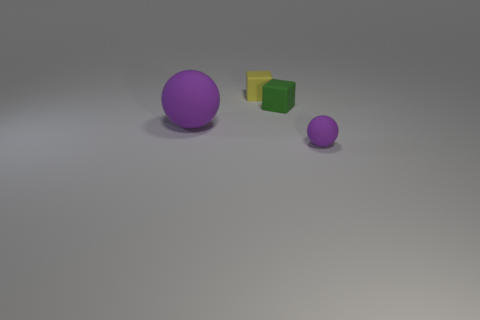Subtract 2 blocks. How many blocks are left? 0 Add 2 purple matte things. How many objects exist? 6 Subtract all small green cubes. Subtract all small yellow matte objects. How many objects are left? 2 Add 3 tiny yellow objects. How many tiny yellow objects are left? 4 Add 4 yellow rubber things. How many yellow rubber things exist? 5 Subtract 0 brown spheres. How many objects are left? 4 Subtract all green blocks. Subtract all cyan cylinders. How many blocks are left? 1 Subtract all cyan cylinders. How many green cubes are left? 1 